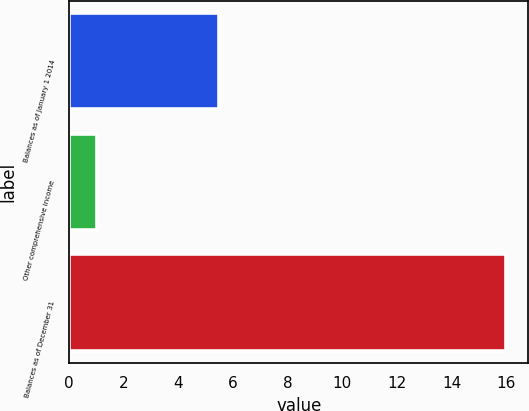Convert chart. <chart><loc_0><loc_0><loc_500><loc_500><bar_chart><fcel>Balances as of January 1 2014<fcel>Other comprehensive income<fcel>Balances as of December 31<nl><fcel>5.5<fcel>1<fcel>16<nl></chart> 